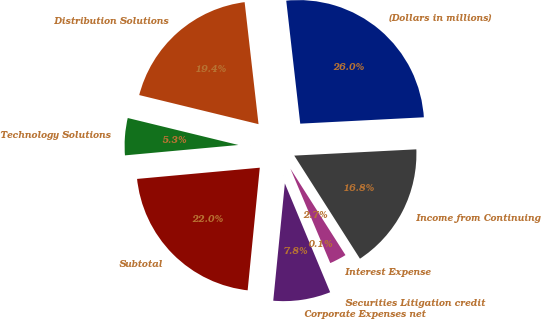Convert chart. <chart><loc_0><loc_0><loc_500><loc_500><pie_chart><fcel>(Dollars in millions)<fcel>Distribution Solutions<fcel>Technology Solutions<fcel>Subtotal<fcel>Corporate Expenses net<fcel>Securities Litigation credit<fcel>Interest Expense<fcel>Income from Continuing<nl><fcel>25.99%<fcel>19.39%<fcel>5.26%<fcel>21.98%<fcel>7.85%<fcel>0.08%<fcel>2.67%<fcel>16.79%<nl></chart> 